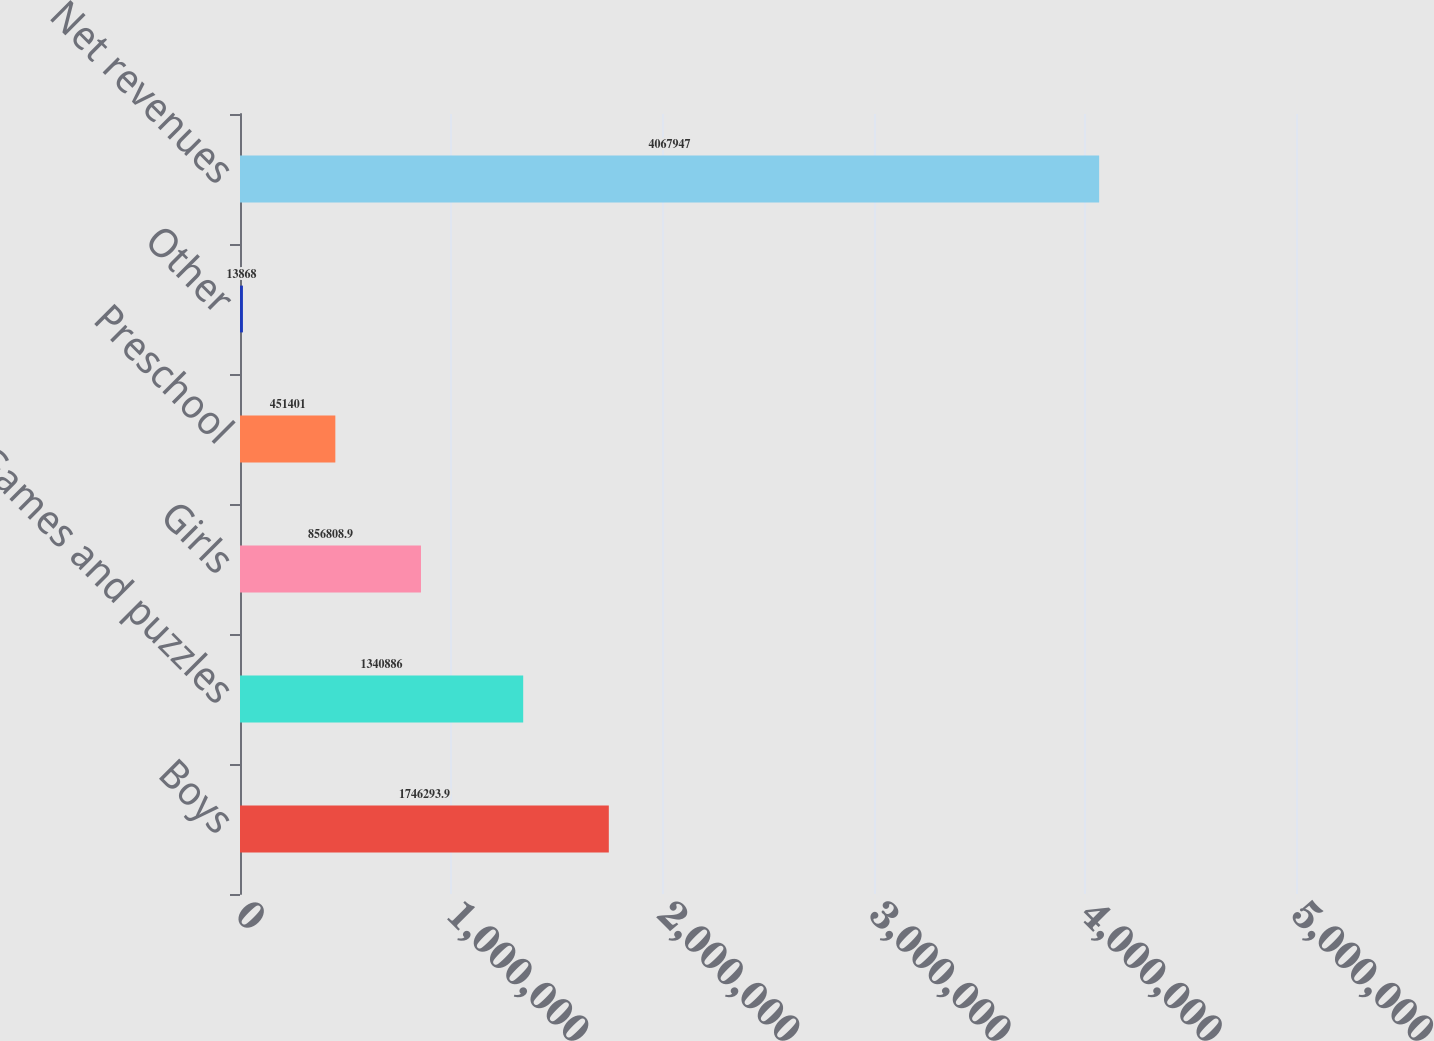<chart> <loc_0><loc_0><loc_500><loc_500><bar_chart><fcel>Boys<fcel>Games and puzzles<fcel>Girls<fcel>Preschool<fcel>Other<fcel>Net revenues<nl><fcel>1.74629e+06<fcel>1.34089e+06<fcel>856809<fcel>451401<fcel>13868<fcel>4.06795e+06<nl></chart> 